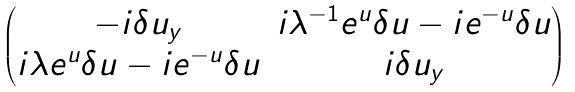Convert formula to latex. <formula><loc_0><loc_0><loc_500><loc_500>\begin{pmatrix} - i \delta u _ { y } & i \lambda ^ { - 1 } e ^ { u } \delta u - i e ^ { - u } \delta u \\ i \lambda e ^ { u } \delta u - i e ^ { - u } \delta u & i \delta u _ { y } \end{pmatrix}</formula> 